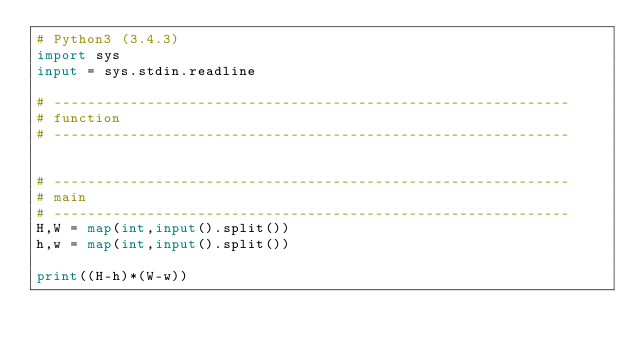<code> <loc_0><loc_0><loc_500><loc_500><_Python_># Python3 (3.4.3)
import sys
input = sys.stdin.readline

# -------------------------------------------------------------
# function
# -------------------------------------------------------------


# -------------------------------------------------------------
# main
# -------------------------------------------------------------
H,W = map(int,input().split())
h,w = map(int,input().split())

print((H-h)*(W-w))</code> 